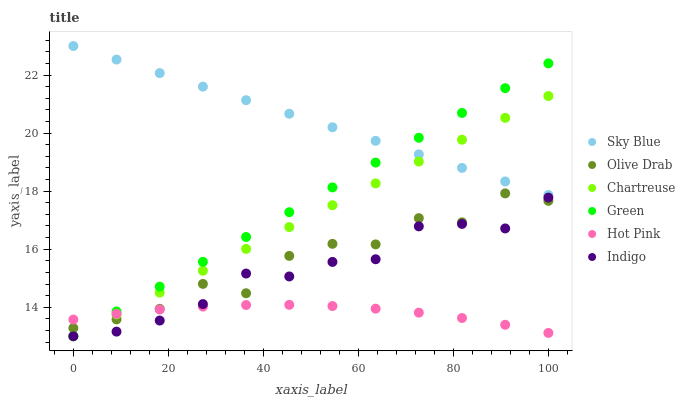Does Hot Pink have the minimum area under the curve?
Answer yes or no. Yes. Does Sky Blue have the maximum area under the curve?
Answer yes or no. Yes. Does Chartreuse have the minimum area under the curve?
Answer yes or no. No. Does Chartreuse have the maximum area under the curve?
Answer yes or no. No. Is Green the smoothest?
Answer yes or no. Yes. Is Olive Drab the roughest?
Answer yes or no. Yes. Is Hot Pink the smoothest?
Answer yes or no. No. Is Hot Pink the roughest?
Answer yes or no. No. Does Indigo have the lowest value?
Answer yes or no. Yes. Does Hot Pink have the lowest value?
Answer yes or no. No. Does Sky Blue have the highest value?
Answer yes or no. Yes. Does Chartreuse have the highest value?
Answer yes or no. No. Is Hot Pink less than Sky Blue?
Answer yes or no. Yes. Is Sky Blue greater than Indigo?
Answer yes or no. Yes. Does Olive Drab intersect Indigo?
Answer yes or no. Yes. Is Olive Drab less than Indigo?
Answer yes or no. No. Is Olive Drab greater than Indigo?
Answer yes or no. No. Does Hot Pink intersect Sky Blue?
Answer yes or no. No. 